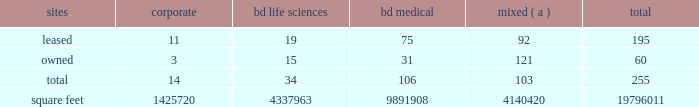The agreements that govern the indebtedness incurred or assumed in connection with the acquisition contain various covenants that impose restrictions on us and certain of our subsidiaries that may affect our ability to operate our businesses .
The agreements that govern the indebtedness incurred or assumed in connection with the carefusion transaction contain various affirmative and negative covenants that may , subject to certain significant exceptions , restrict our ability and the ability of certain of our subsidiaries ( including carefusion ) to , among other things , have liens on their property , transact business with affiliates and/or merge or consolidate with any other person or sell or convey certain of our assets to any one person .
In addition , some of the agreements that govern our indebtedness contain financial covenants that will require us to maintain certain financial ratios .
Our ability and the ability of our subsidiaries to comply with these provisions may be affected by events beyond our control .
Failure to comply with these covenants could result in an event of default , which , if not cured or waived , could accelerate our repayment obligations .
Item 1b .
Unresolved staff comments .
Item 2 .
Properties .
Bd 2019s executive offices are located in franklin lakes , new jersey .
As of october 31 , 2016 , bd owned or leased 255 facilities throughout the world , comprising approximately 19796011 square feet of manufacturing , warehousing , administrative and research facilities .
The u.s .
Facilities , including those in puerto rico , comprise approximately 7459856 square feet of owned and 2923257 square feet of leased space .
The international facilities comprise approximately 7189652 square feet of owned and 2223245 square feet of leased space .
Sales offices and distribution centers included in the total square footage are also located throughout the world .
Operations in each of bd 2019s business segments are conducted at both u.s .
And international locations .
Particularly in the international marketplace , facilities often serve more than one business segment and are used for multiple purposes , such as administrative/sales , manufacturing and/or warehousing/distribution .
Bd generally seeks to own its manufacturing facilities , although some are leased .
The table summarizes property information by business segment. .
( a ) facilities used by more than one business segment .
Bd believes that its facilities are of good construction and in good physical condition , are suitable and adequate for the operations conducted at those facilities , and are , with minor exceptions , fully utilized and operating at normal capacity .
The u.s .
Facilities are located in alabama , arizona , california , connecticut , florida , georgia , illinois , indiana , maryland , massachusetts , michigan , nebraska , new jersey , north carolina , ohio , oklahoma , south carolina , texas , utah , virginia , washington , d.c. , washington , wisconsin and puerto rico .
The international facilities are as follows : - europe , middle east , africa , which includes facilities in austria , belgium , bosnia and herzegovina , the czech republic , denmark , england , finland , france , germany , ghana , hungary , ireland , italy , kenya , luxembourg , netherlands , norway , poland , portugal , russia , saudi arabia , south africa , spain , sweden , switzerland , turkey , the united arab emirates and zambia. .
What was the percent of the total international facilities square feet of owned by bd? 
Computations: (7189652 / (7189652 + 2223245))
Answer: 0.76381. 